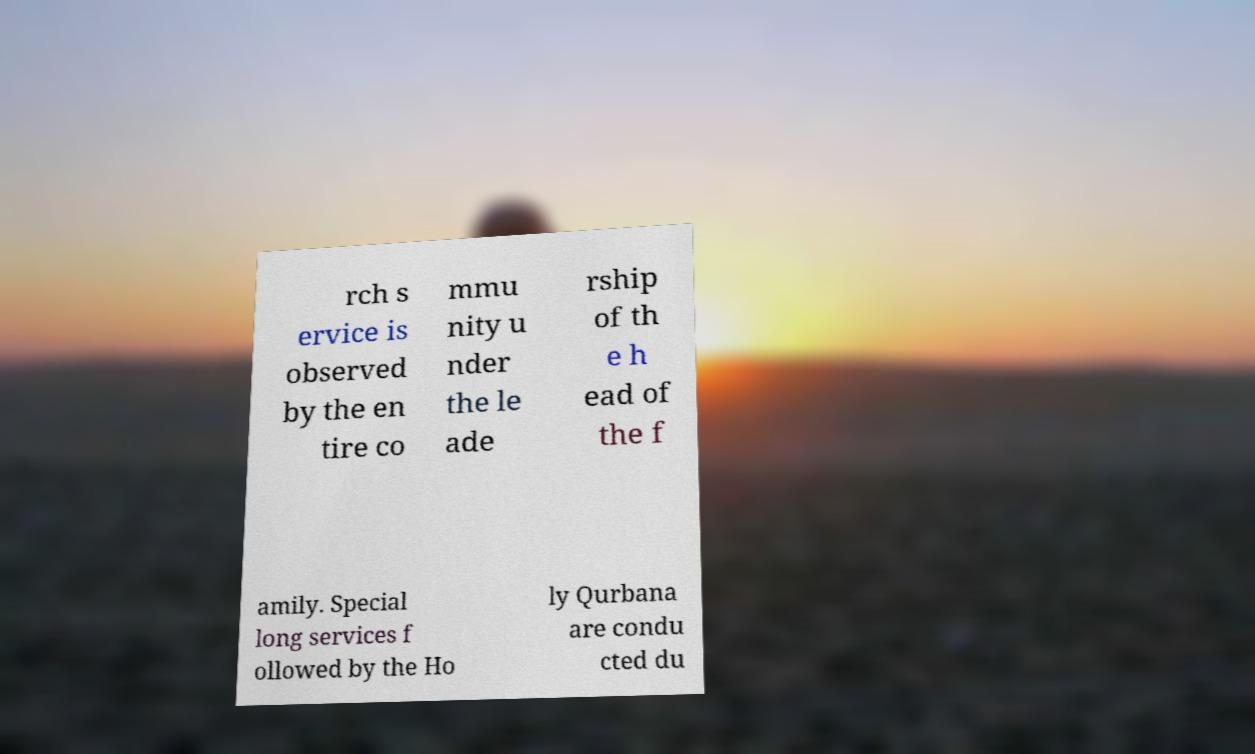For documentation purposes, I need the text within this image transcribed. Could you provide that? rch s ervice is observed by the en tire co mmu nity u nder the le ade rship of th e h ead of the f amily. Special long services f ollowed by the Ho ly Qurbana are condu cted du 